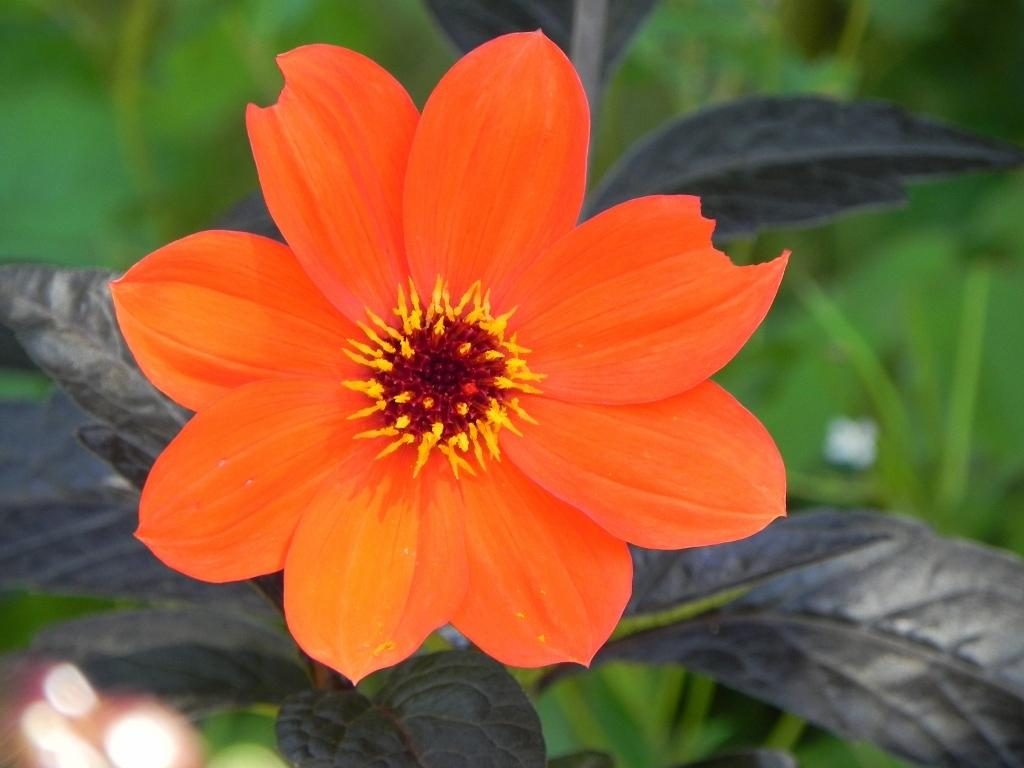What type of flower is in the image? There is an orange flower in the image. Where is the flower located? The flower is on a plant. How many legs does the flower have in the image? Flowers do not have legs, so this question cannot be answered. 